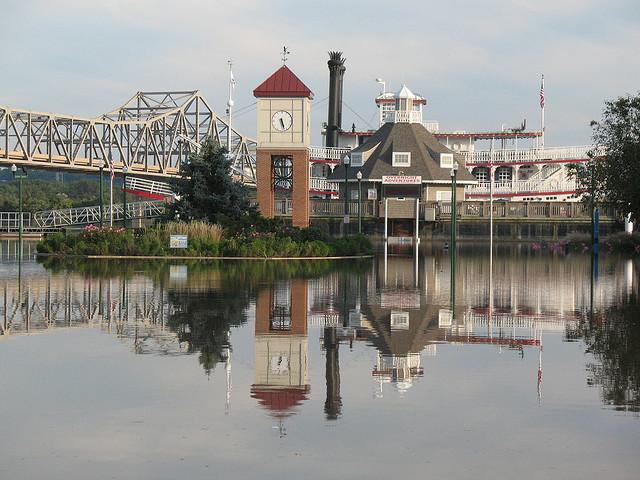What color is the water?
Write a very short answer. Gray. What time is on the clock tower?
Short answer required. 5:25. Is this in the desert?
Answer briefly. No. Where is the bridge?
Short answer required. Over water. How many boats do you see?
Concise answer only. 0. 